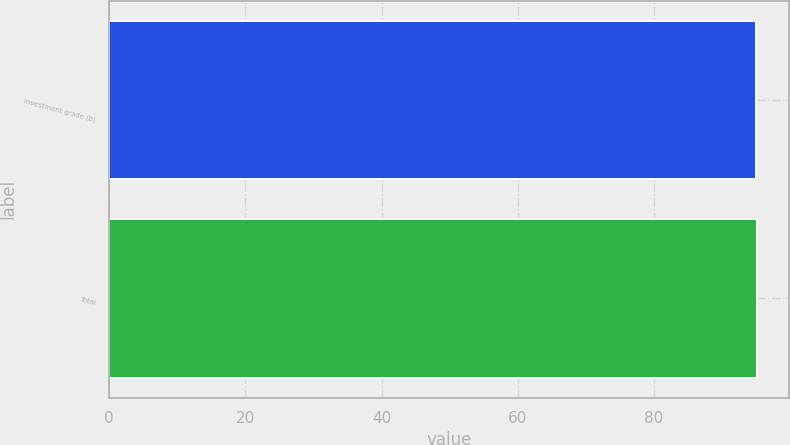Convert chart. <chart><loc_0><loc_0><loc_500><loc_500><bar_chart><fcel>Investment grade (b)<fcel>Total<nl><fcel>95<fcel>95.1<nl></chart> 